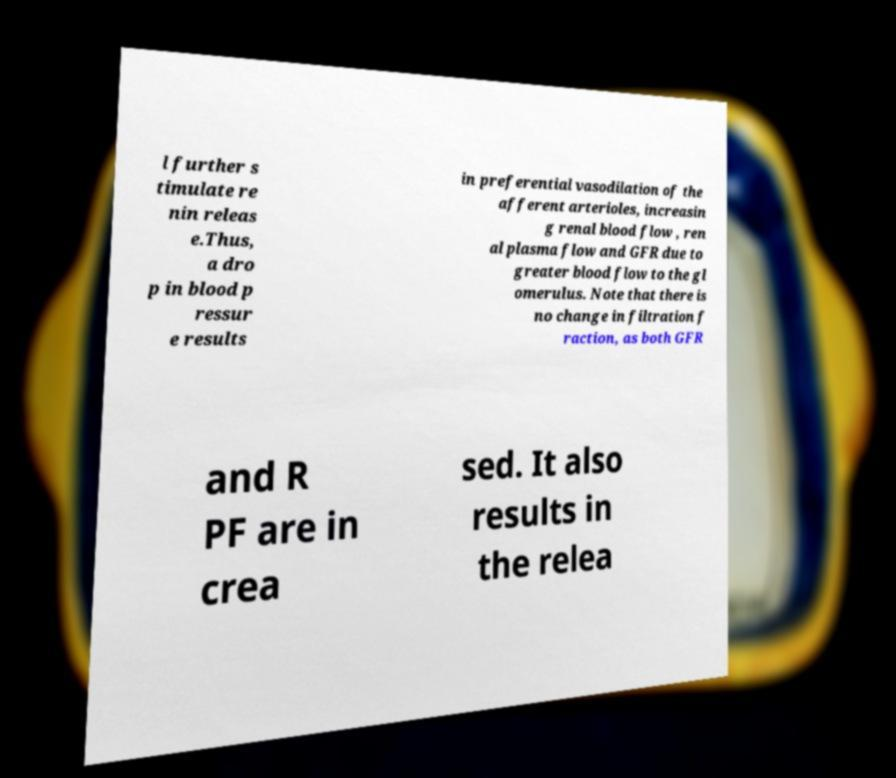Can you read and provide the text displayed in the image?This photo seems to have some interesting text. Can you extract and type it out for me? l further s timulate re nin releas e.Thus, a dro p in blood p ressur e results in preferential vasodilation of the afferent arterioles, increasin g renal blood flow , ren al plasma flow and GFR due to greater blood flow to the gl omerulus. Note that there is no change in filtration f raction, as both GFR and R PF are in crea sed. It also results in the relea 